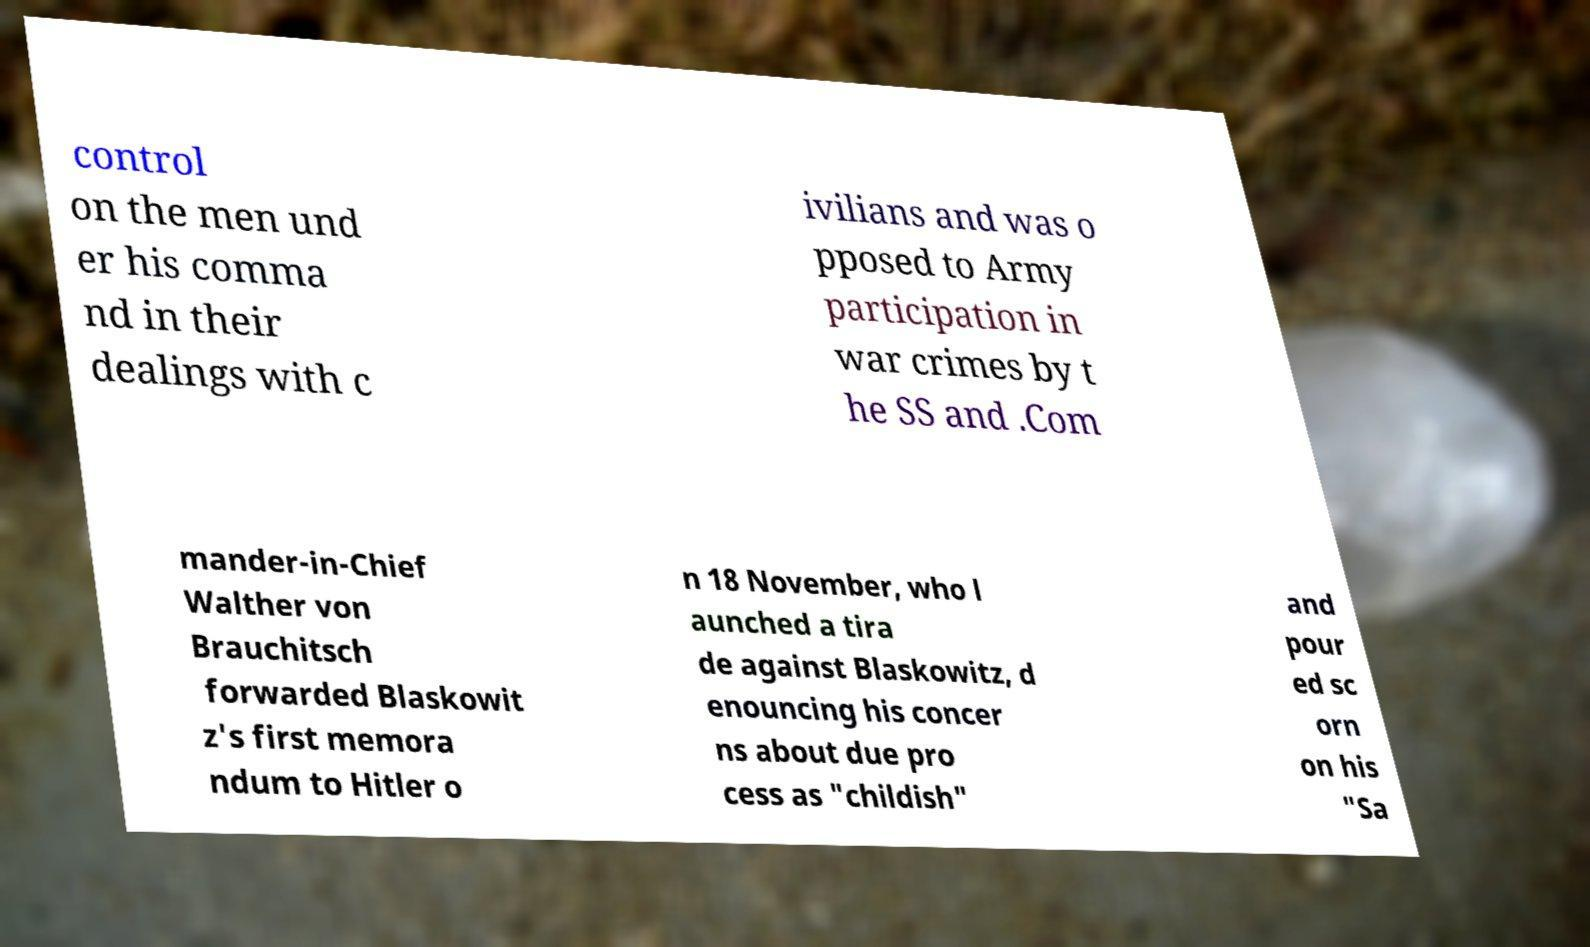I need the written content from this picture converted into text. Can you do that? control on the men und er his comma nd in their dealings with c ivilians and was o pposed to Army participation in war crimes by t he SS and .Com mander-in-Chief Walther von Brauchitsch forwarded Blaskowit z's first memora ndum to Hitler o n 18 November, who l aunched a tira de against Blaskowitz, d enouncing his concer ns about due pro cess as "childish" and pour ed sc orn on his "Sa 